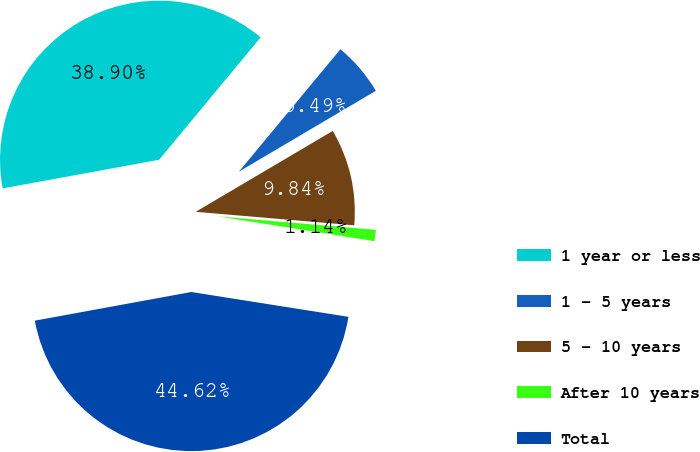Convert chart. <chart><loc_0><loc_0><loc_500><loc_500><pie_chart><fcel>1 year or less<fcel>1 - 5 years<fcel>5 - 10 years<fcel>After 10 years<fcel>Total<nl><fcel>38.9%<fcel>5.49%<fcel>9.84%<fcel>1.14%<fcel>44.62%<nl></chart> 